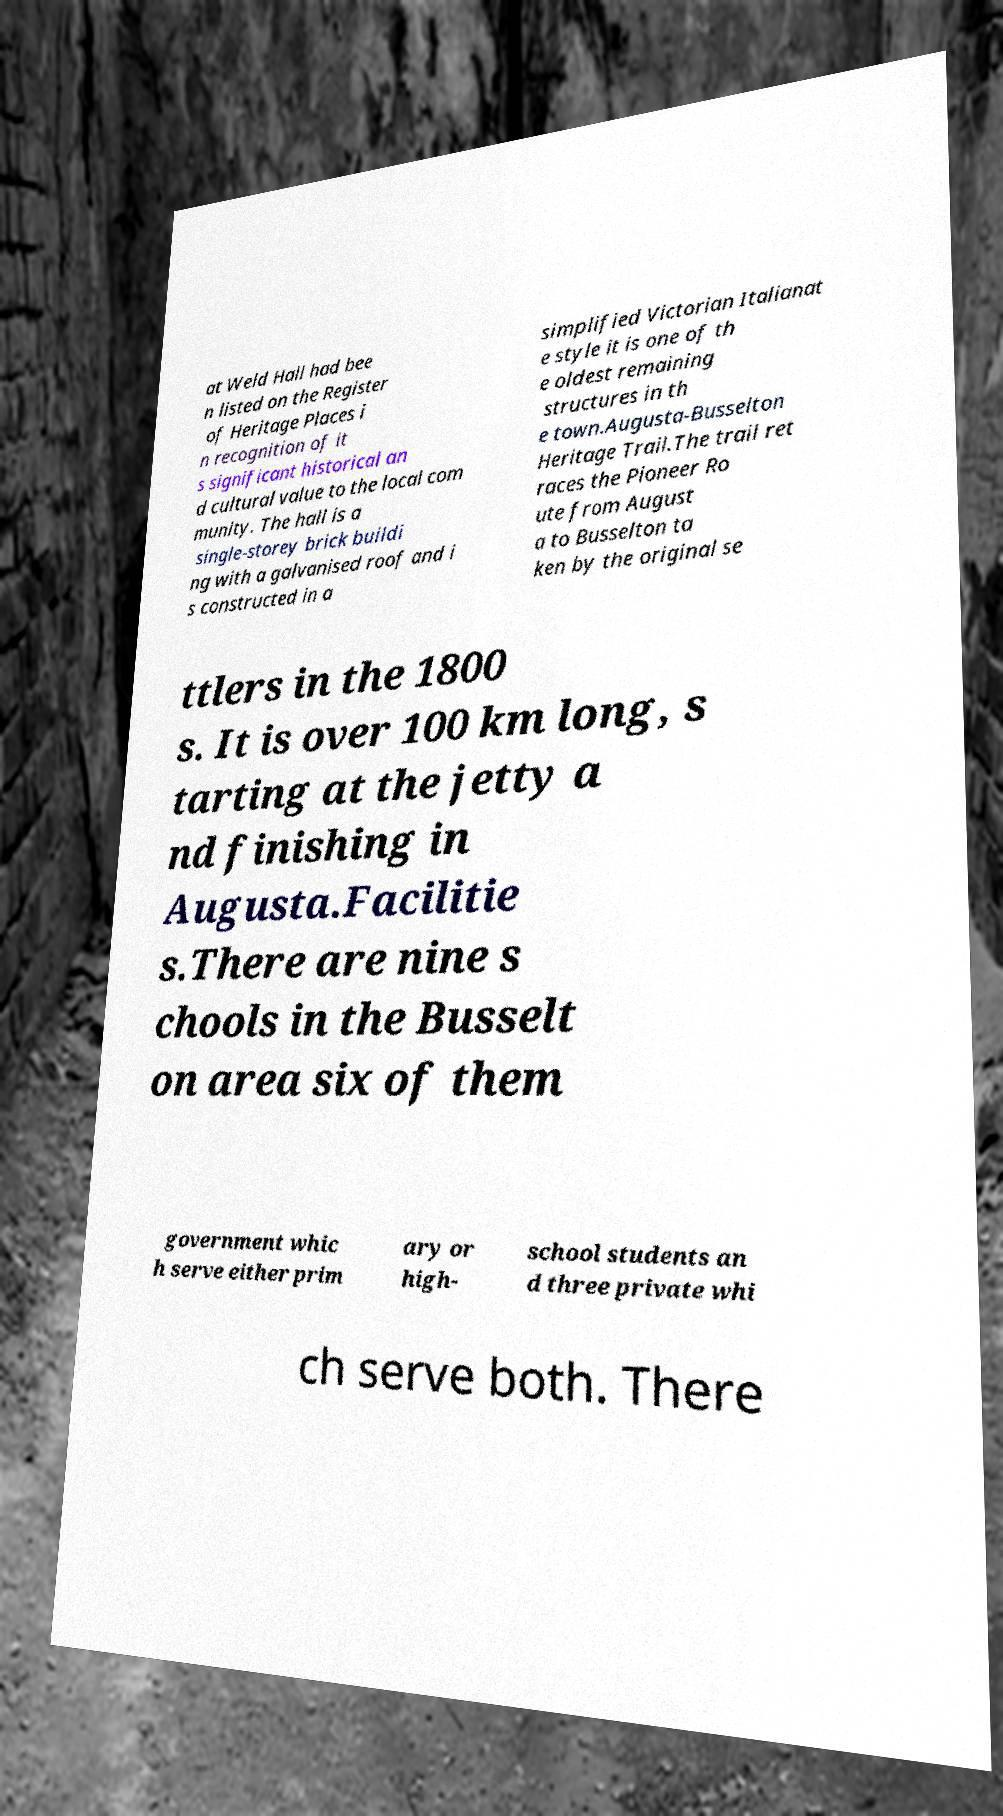Could you extract and type out the text from this image? at Weld Hall had bee n listed on the Register of Heritage Places i n recognition of it s significant historical an d cultural value to the local com munity. The hall is a single-storey brick buildi ng with a galvanised roof and i s constructed in a simplified Victorian Italianat e style it is one of th e oldest remaining structures in th e town.Augusta-Busselton Heritage Trail.The trail ret races the Pioneer Ro ute from August a to Busselton ta ken by the original se ttlers in the 1800 s. It is over 100 km long, s tarting at the jetty a nd finishing in Augusta.Facilitie s.There are nine s chools in the Busselt on area six of them government whic h serve either prim ary or high- school students an d three private whi ch serve both. There 